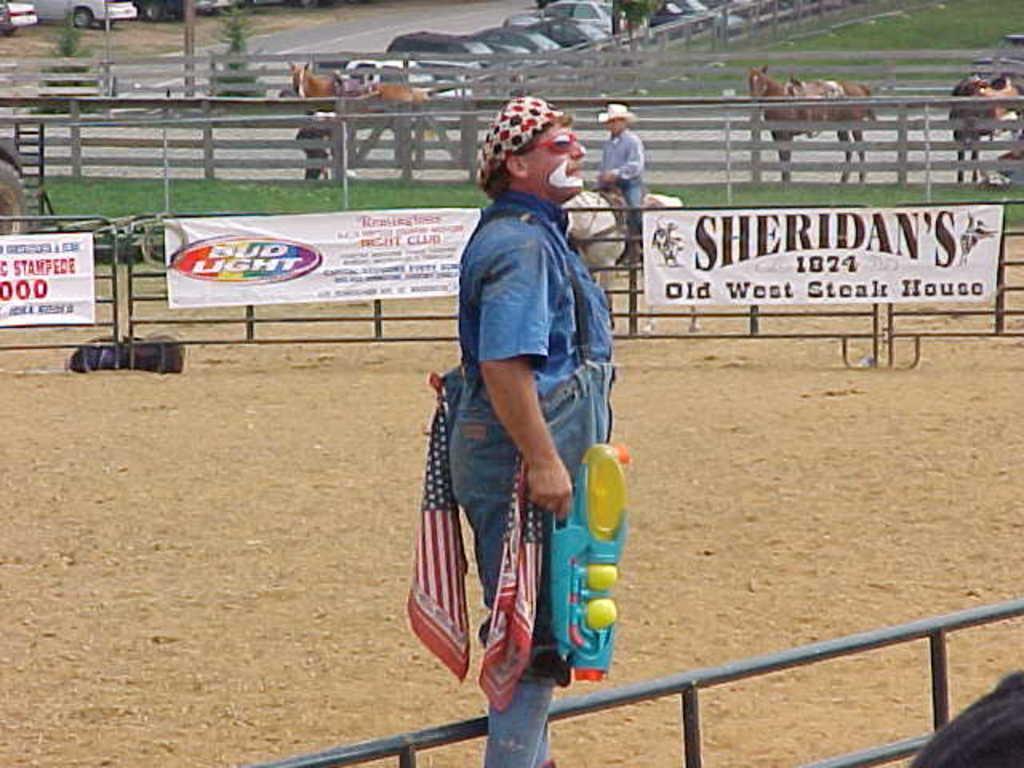Can you describe this image briefly? This picture shows a man standing and holding a gun in his hand and we see a man riding horse and we see few horses on the side and few parked cars 